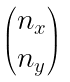Convert formula to latex. <formula><loc_0><loc_0><loc_500><loc_500>\begin{pmatrix} n _ { x } \\ n _ { y } \end{pmatrix}</formula> 